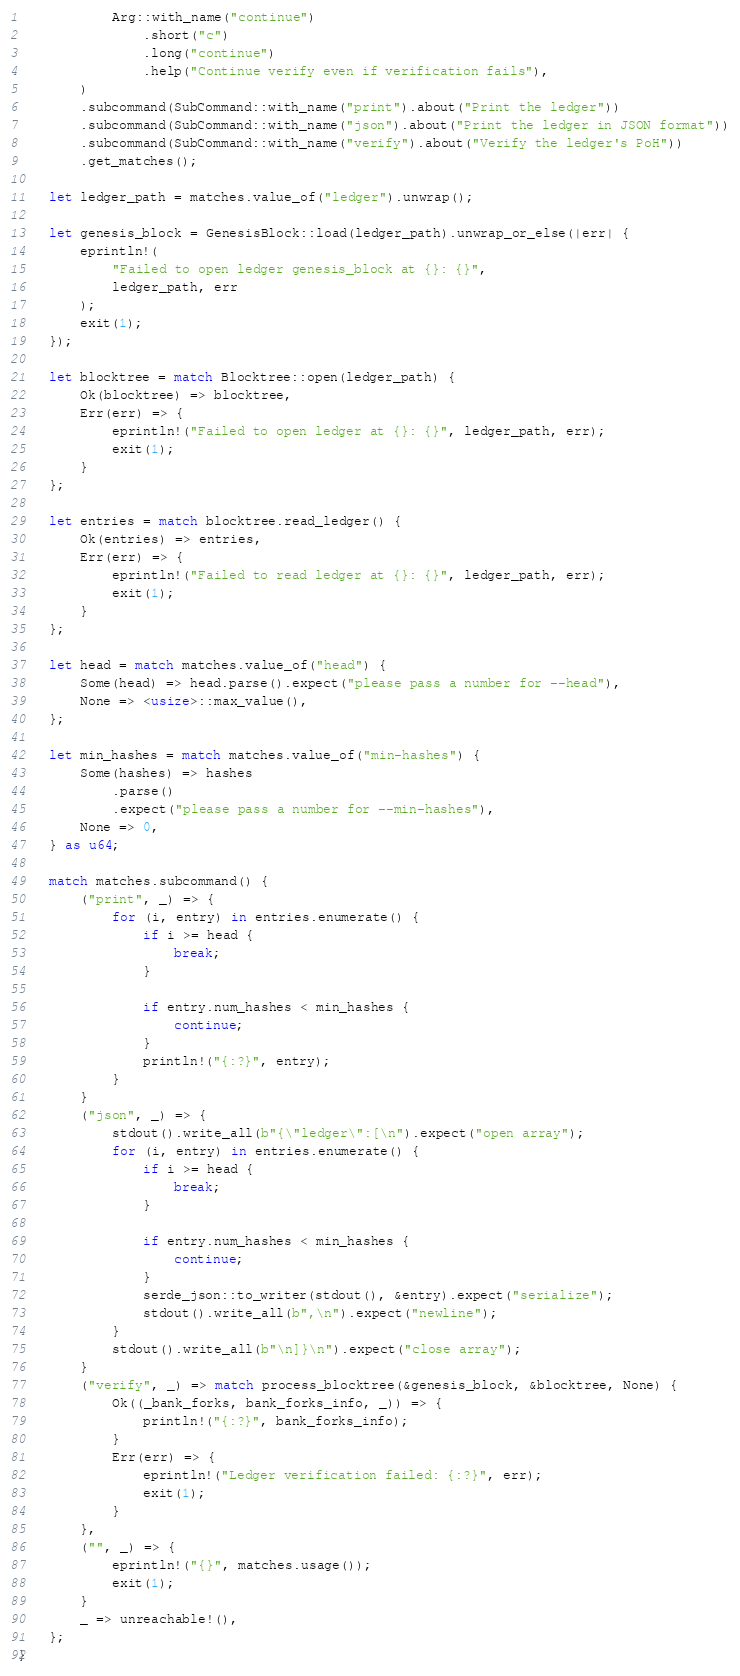Convert code to text. <code><loc_0><loc_0><loc_500><loc_500><_Rust_>            Arg::with_name("continue")
                .short("c")
                .long("continue")
                .help("Continue verify even if verification fails"),
        )
        .subcommand(SubCommand::with_name("print").about("Print the ledger"))
        .subcommand(SubCommand::with_name("json").about("Print the ledger in JSON format"))
        .subcommand(SubCommand::with_name("verify").about("Verify the ledger's PoH"))
        .get_matches();

    let ledger_path = matches.value_of("ledger").unwrap();

    let genesis_block = GenesisBlock::load(ledger_path).unwrap_or_else(|err| {
        eprintln!(
            "Failed to open ledger genesis_block at {}: {}",
            ledger_path, err
        );
        exit(1);
    });

    let blocktree = match Blocktree::open(ledger_path) {
        Ok(blocktree) => blocktree,
        Err(err) => {
            eprintln!("Failed to open ledger at {}: {}", ledger_path, err);
            exit(1);
        }
    };

    let entries = match blocktree.read_ledger() {
        Ok(entries) => entries,
        Err(err) => {
            eprintln!("Failed to read ledger at {}: {}", ledger_path, err);
            exit(1);
        }
    };

    let head = match matches.value_of("head") {
        Some(head) => head.parse().expect("please pass a number for --head"),
        None => <usize>::max_value(),
    };

    let min_hashes = match matches.value_of("min-hashes") {
        Some(hashes) => hashes
            .parse()
            .expect("please pass a number for --min-hashes"),
        None => 0,
    } as u64;

    match matches.subcommand() {
        ("print", _) => {
            for (i, entry) in entries.enumerate() {
                if i >= head {
                    break;
                }

                if entry.num_hashes < min_hashes {
                    continue;
                }
                println!("{:?}", entry);
            }
        }
        ("json", _) => {
            stdout().write_all(b"{\"ledger\":[\n").expect("open array");
            for (i, entry) in entries.enumerate() {
                if i >= head {
                    break;
                }

                if entry.num_hashes < min_hashes {
                    continue;
                }
                serde_json::to_writer(stdout(), &entry).expect("serialize");
                stdout().write_all(b",\n").expect("newline");
            }
            stdout().write_all(b"\n]}\n").expect("close array");
        }
        ("verify", _) => match process_blocktree(&genesis_block, &blocktree, None) {
            Ok((_bank_forks, bank_forks_info, _)) => {
                println!("{:?}", bank_forks_info);
            }
            Err(err) => {
                eprintln!("Ledger verification failed: {:?}", err);
                exit(1);
            }
        },
        ("", _) => {
            eprintln!("{}", matches.usage());
            exit(1);
        }
        _ => unreachable!(),
    };
}
</code> 